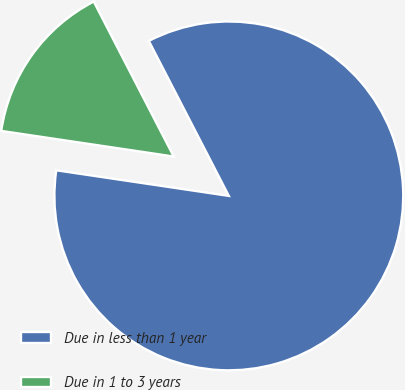<chart> <loc_0><loc_0><loc_500><loc_500><pie_chart><fcel>Due in less than 1 year<fcel>Due in 1 to 3 years<nl><fcel>84.93%<fcel>15.07%<nl></chart> 